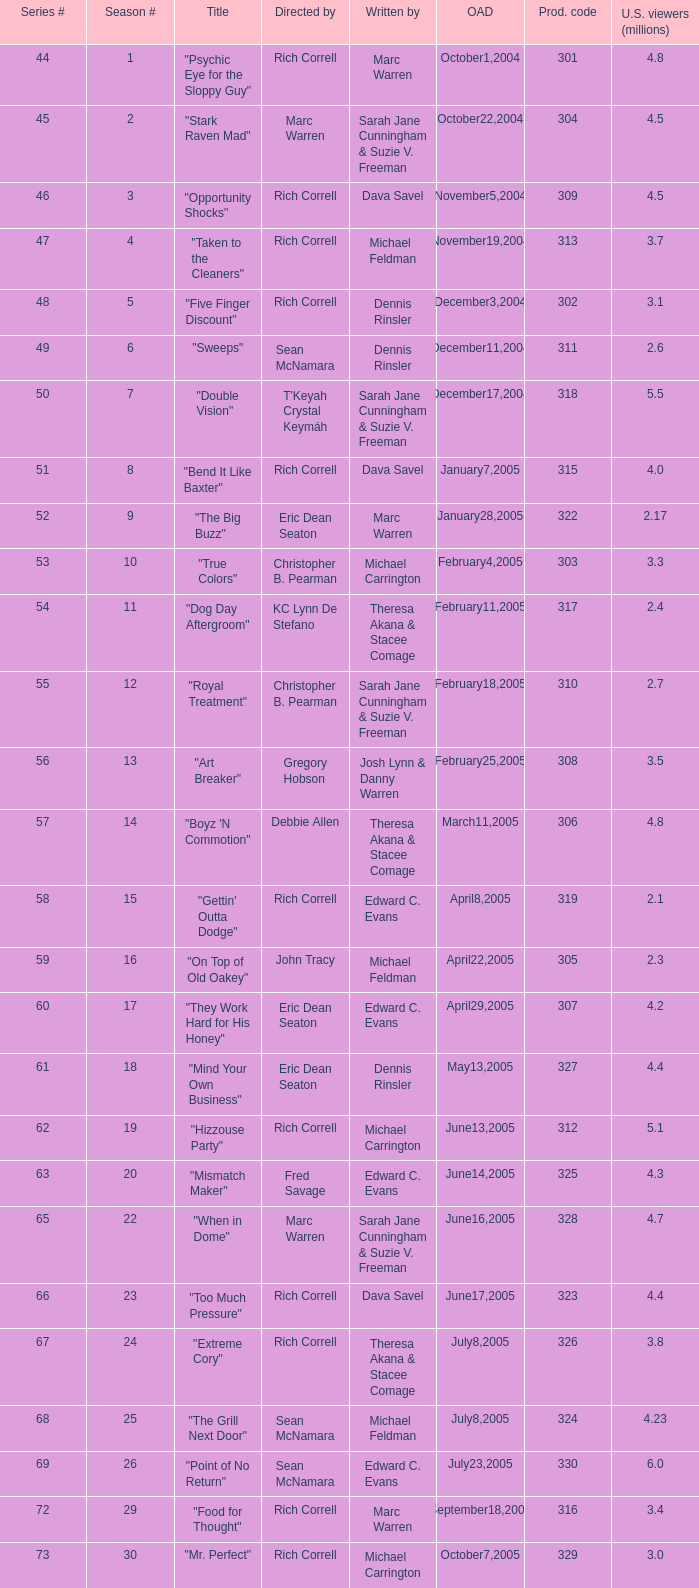What number episode in the season had a production code of 334? 32.0. 